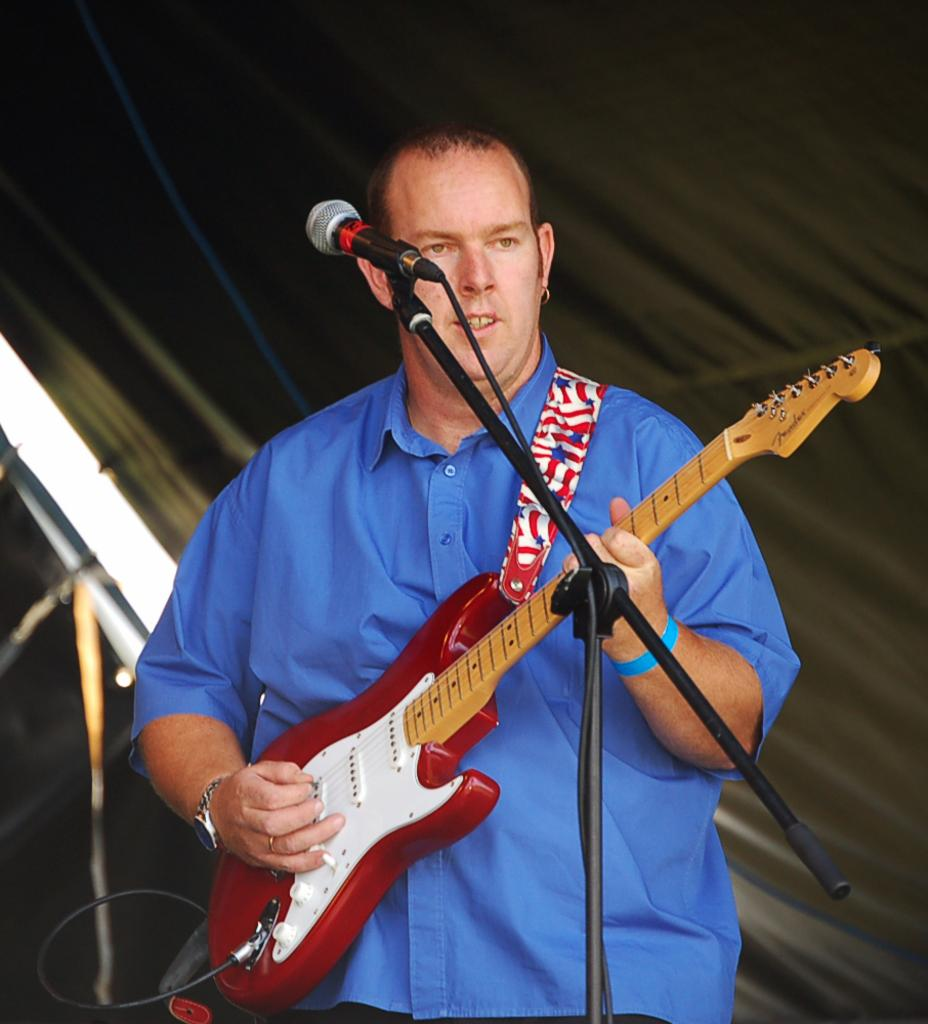Where was the image taken? The image was taken indoors. What is the man in the image doing? The man is standing in the middle of the image and playing a guitar. What object is present for amplifying sound? There is a microphone in the image. What can be seen in the background of the image? There is a curtain in the background of the image. What type of bun is the man holding in the image? There is no bun present in the image; the man is playing a guitar. Is the queen present in the image? There is no queen present in the image; it features a man playing a guitar. 